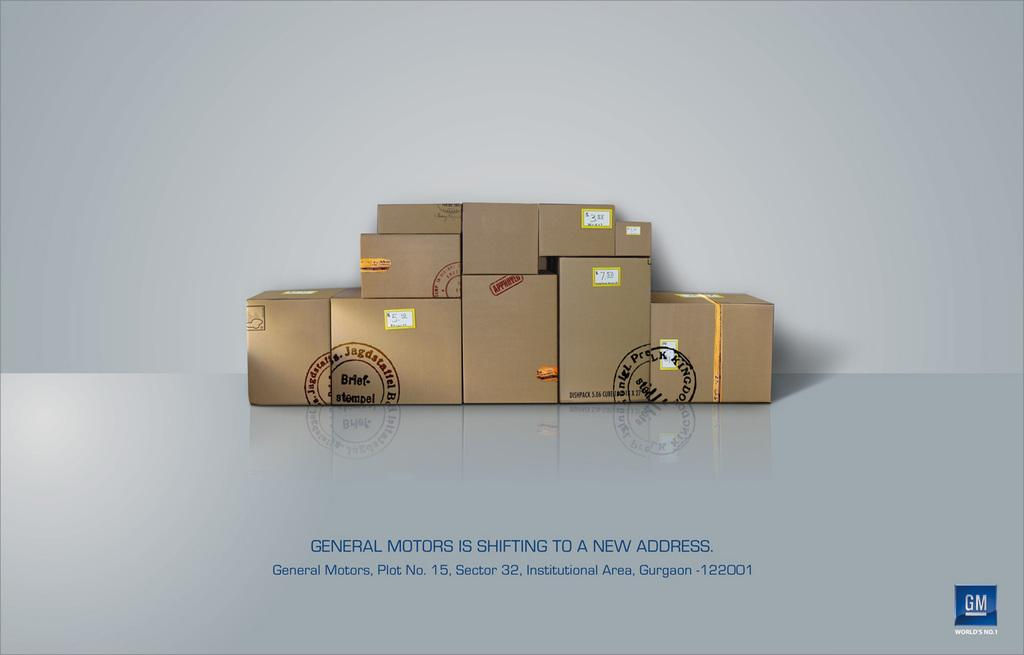<image>
Render a clear and concise summary of the photo. an ad for GM containing ten boxes on a floor 